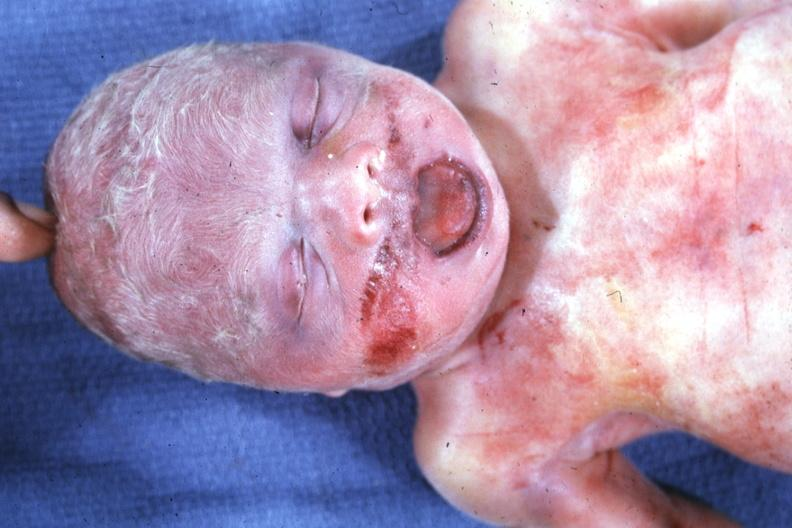what is present?
Answer the question using a single word or phrase. Beckwith-wiedemann syndrome 